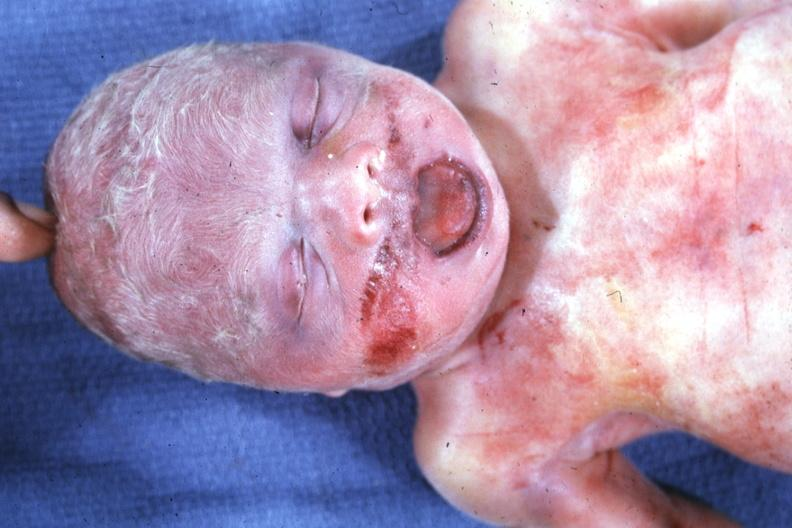what is present?
Answer the question using a single word or phrase. Beckwith-wiedemann syndrome 